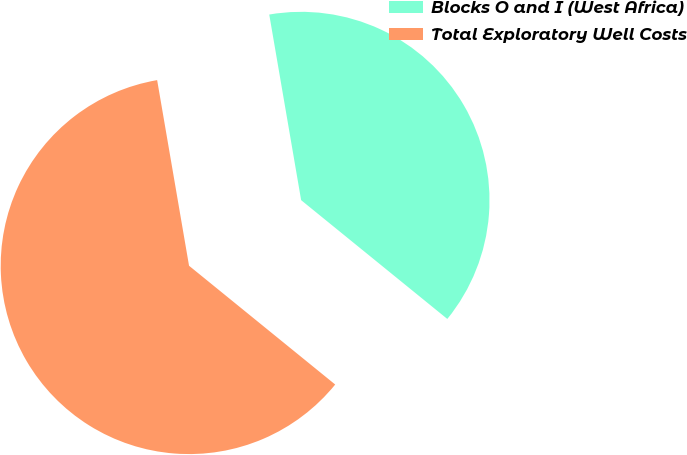Convert chart to OTSL. <chart><loc_0><loc_0><loc_500><loc_500><pie_chart><fcel>Blocks O and I (West Africa)<fcel>Total Exploratory Well Costs<nl><fcel>38.57%<fcel>61.43%<nl></chart> 